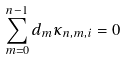<formula> <loc_0><loc_0><loc_500><loc_500>\sum _ { m = 0 } ^ { n - 1 } d _ { m } \kappa _ { n , m , i } = 0</formula> 